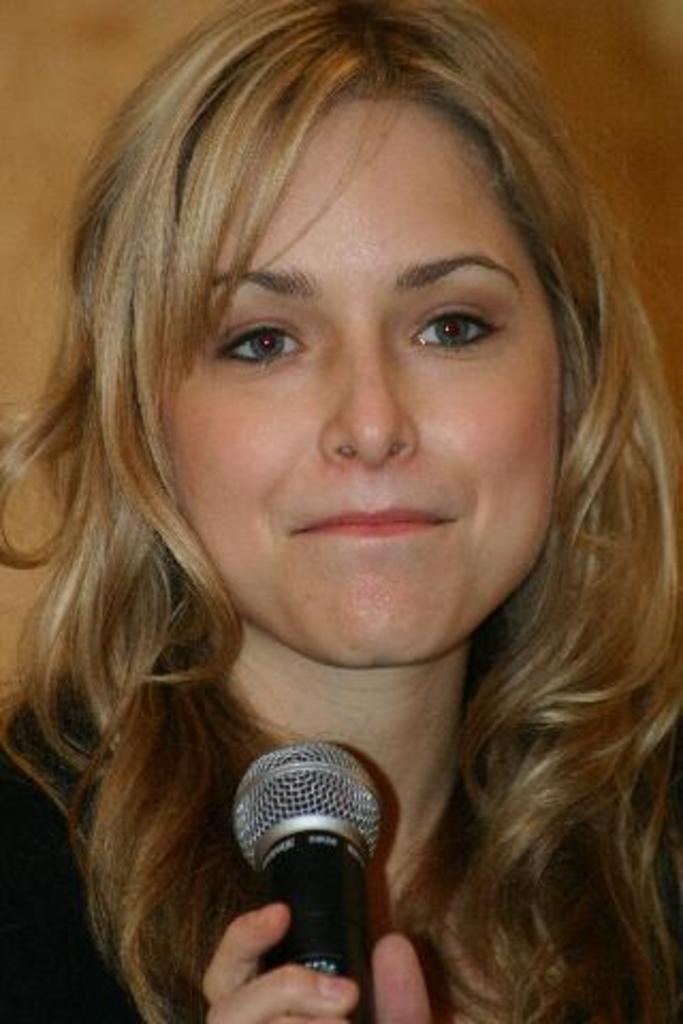What is the main subject of the picture? The main subject of the picture is a beautiful girl. Can you describe the girl's hair color? The girl has golden brown hair. What is the girl's expression in the picture? The girl is smiling in the picture. What is the girl holding in her hand? The girl is holding a microphone in her hand. What is the girl doing in the picture? The girl is giving a pose in the photograph. Is the girl wearing a crown in the picture? There is no crown visible on the girl in the picture. What type of event is the girl attending in the image? The provided facts do not mention any event, so it cannot be determined from the image. 